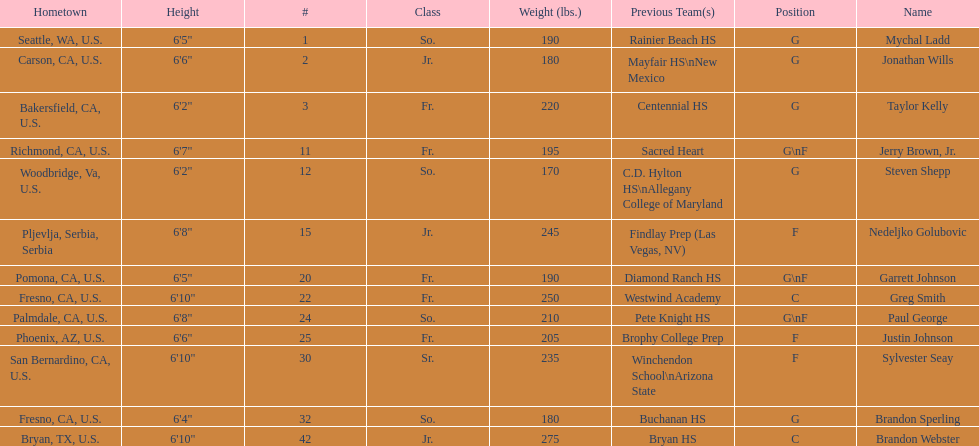Which player who is only a forward (f) is the shortest? Justin Johnson. 